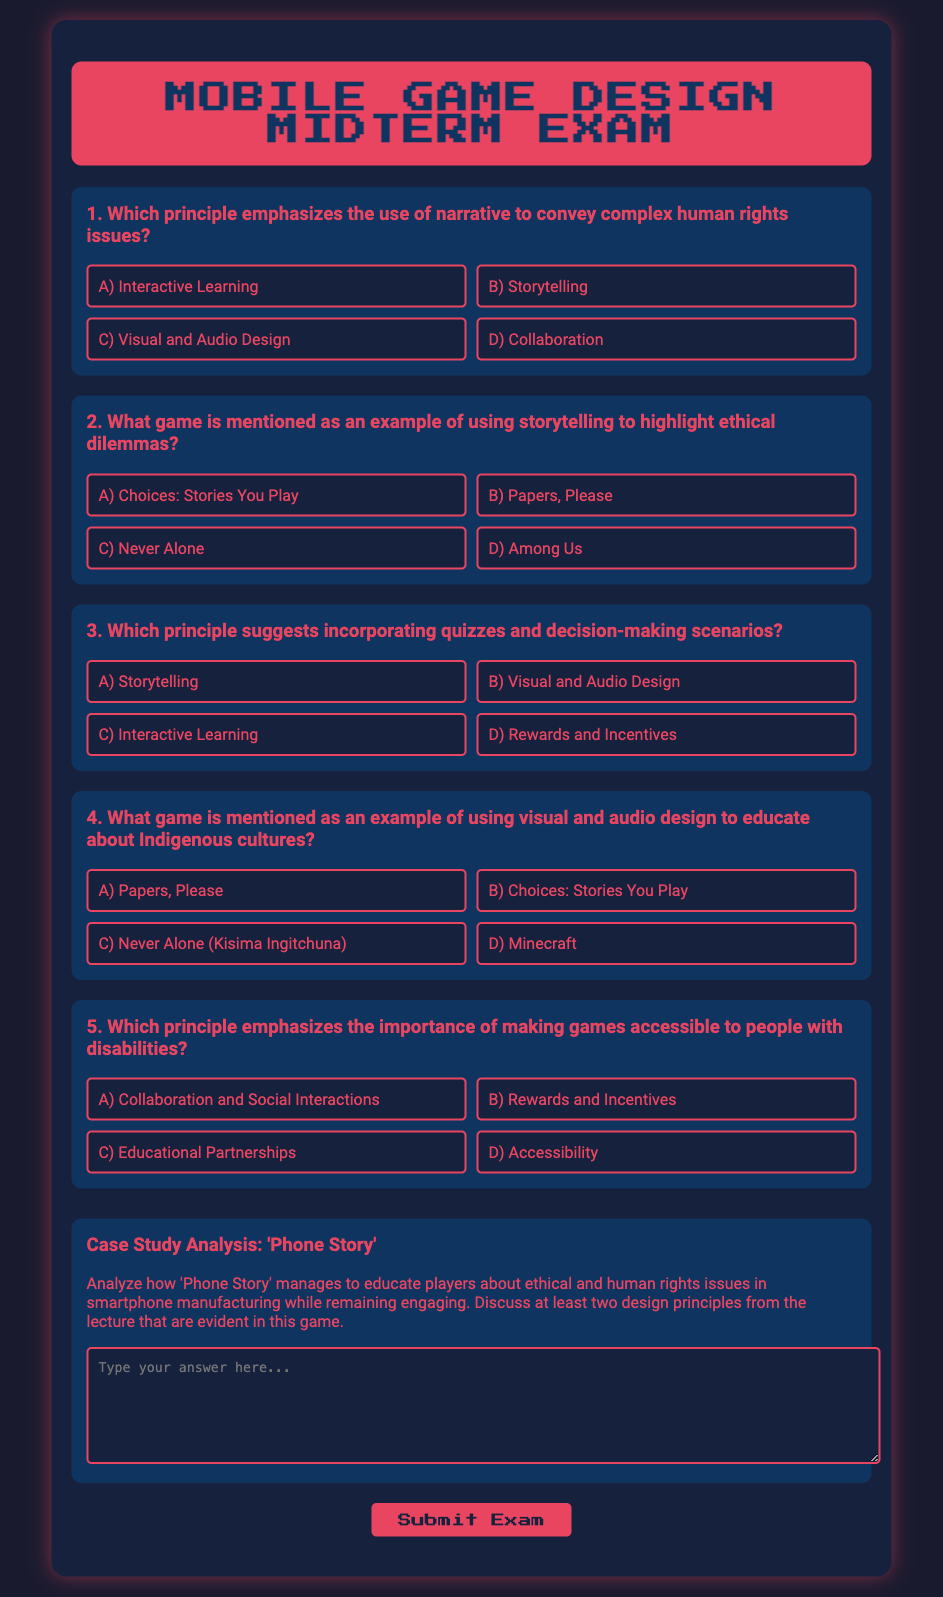What principle emphasizes the use of narrative to convey complex human rights issues? The question asks for the principle that specifically highlights the use of narrative, which is mentioned in the document.
Answer: Storytelling What game is mentioned as an example of using storytelling to highlight ethical dilemmas? The question seeks the name of the game from the document that is noted for using storytelling effectively.
Answer: Papers, Please Which principle suggests incorporating quizzes and decision-making scenarios? This question targets the design principle that directly relates to interactivity and learning through quizzes.
Answer: Interactive Learning What game is mentioned as an example of using visual and audio design to educate about Indigenous cultures? Here, the question is looking for the specific game referred to in the document that utilizes visual and audio design for educational purposes.
Answer: Never Alone (Kisima Ingitchuna) Which principle emphasizes the importance of making games accessible to people with disabilities? This question focuses on identifying the specific principle related to accessibility outlined in the document.
Answer: Accessibility What is the title of the case study analyzed in the document? This question looks for the title of the case study that is included in the midterm exam.
Answer: Phone Story How many questions are presented in the midterm exam? This question requires a count of the number of distinct questions found in the document.
Answer: 5 What color is used for the background of the container in the midterm exam? The question seeks specific information about the color design choice made for the document's layout.
Answer: #16213e 